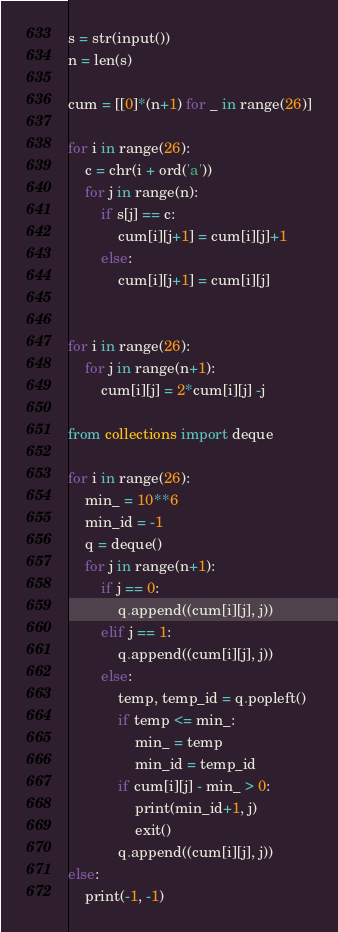<code> <loc_0><loc_0><loc_500><loc_500><_Python_>s = str(input())
n = len(s)

cum = [[0]*(n+1) for _ in range(26)]

for i in range(26):
    c = chr(i + ord('a'))
    for j in range(n):
        if s[j] == c:
            cum[i][j+1] = cum[i][j]+1
        else:
            cum[i][j+1] = cum[i][j]


for i in range(26):
    for j in range(n+1):
        cum[i][j] = 2*cum[i][j] -j

from collections import deque

for i in range(26):
    min_ = 10**6
    min_id = -1
    q = deque()
    for j in range(n+1):
        if j == 0:
            q.append((cum[i][j], j))
        elif j == 1:
            q.append((cum[i][j], j))
        else:
            temp, temp_id = q.popleft()
            if temp <= min_:
                min_ = temp
                min_id = temp_id
            if cum[i][j] - min_ > 0:
                print(min_id+1, j)
                exit()
            q.append((cum[i][j], j))
else:
    print(-1, -1)</code> 